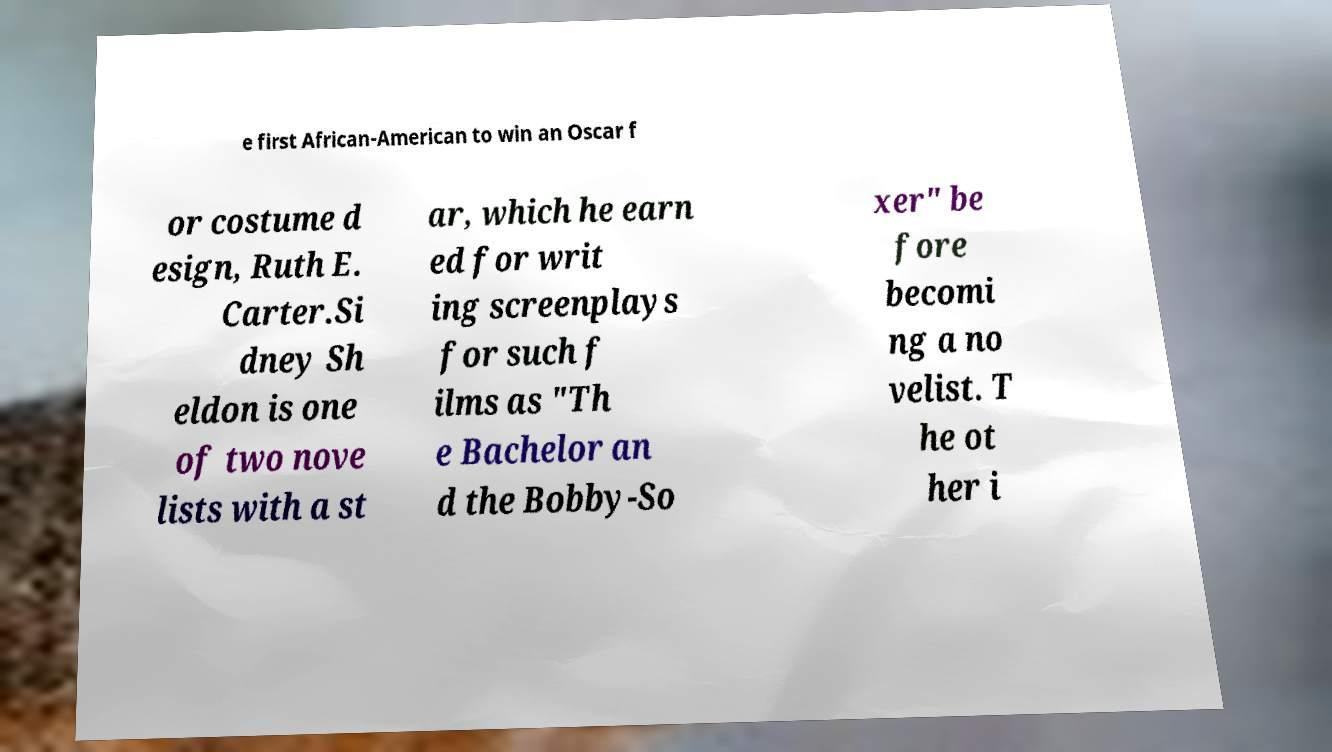Could you extract and type out the text from this image? e first African-American to win an Oscar f or costume d esign, Ruth E. Carter.Si dney Sh eldon is one of two nove lists with a st ar, which he earn ed for writ ing screenplays for such f ilms as "Th e Bachelor an d the Bobby-So xer" be fore becomi ng a no velist. T he ot her i 